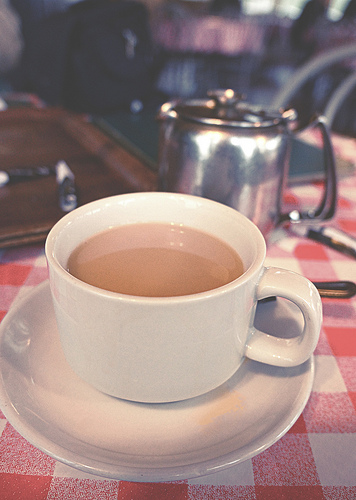<image>
Is there a cup in front of the saucer? No. The cup is not in front of the saucer. The spatial positioning shows a different relationship between these objects. 